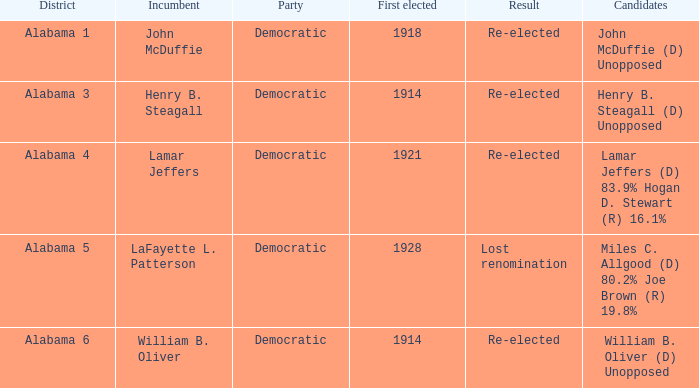How many individuals who lost renomination were initially elected? 1928.0. 